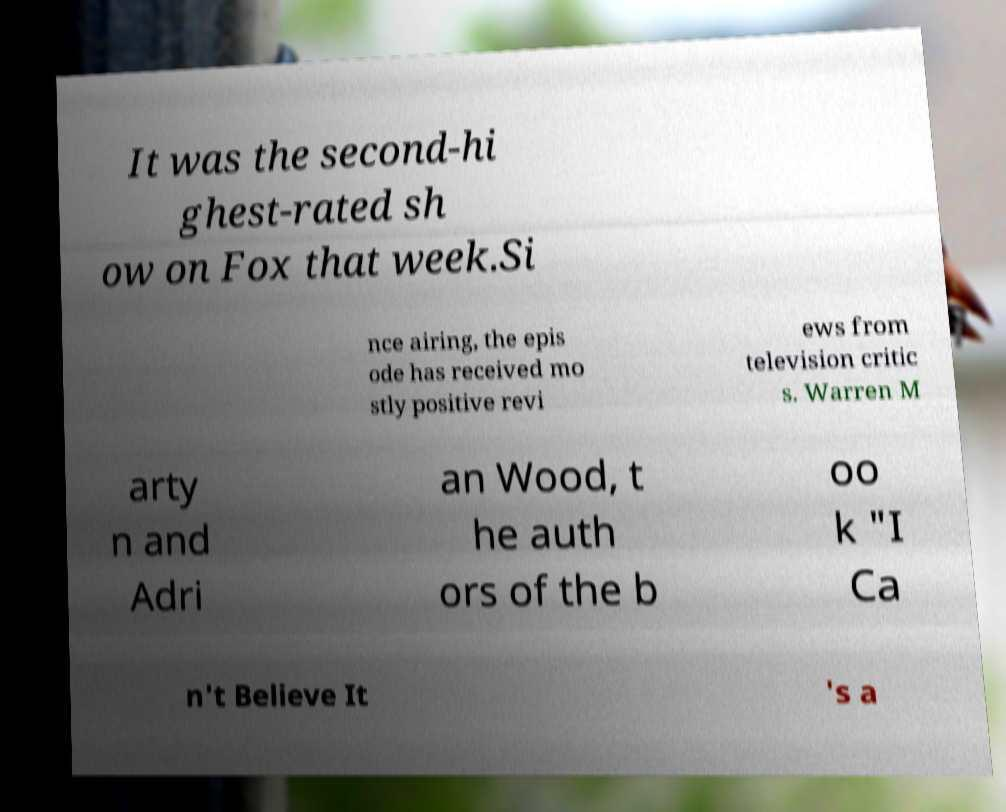I need the written content from this picture converted into text. Can you do that? It was the second-hi ghest-rated sh ow on Fox that week.Si nce airing, the epis ode has received mo stly positive revi ews from television critic s. Warren M arty n and Adri an Wood, t he auth ors of the b oo k "I Ca n't Believe It 's a 